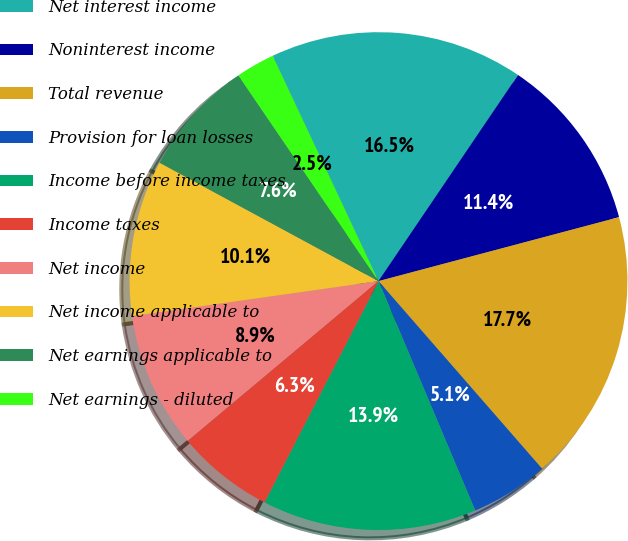Convert chart to OTSL. <chart><loc_0><loc_0><loc_500><loc_500><pie_chart><fcel>Net interest income<fcel>Noninterest income<fcel>Total revenue<fcel>Provision for loan losses<fcel>Income before income taxes<fcel>Income taxes<fcel>Net income<fcel>Net income applicable to<fcel>Net earnings applicable to<fcel>Net earnings - diluted<nl><fcel>16.46%<fcel>11.39%<fcel>17.72%<fcel>5.06%<fcel>13.92%<fcel>6.33%<fcel>8.86%<fcel>10.13%<fcel>7.59%<fcel>2.53%<nl></chart> 